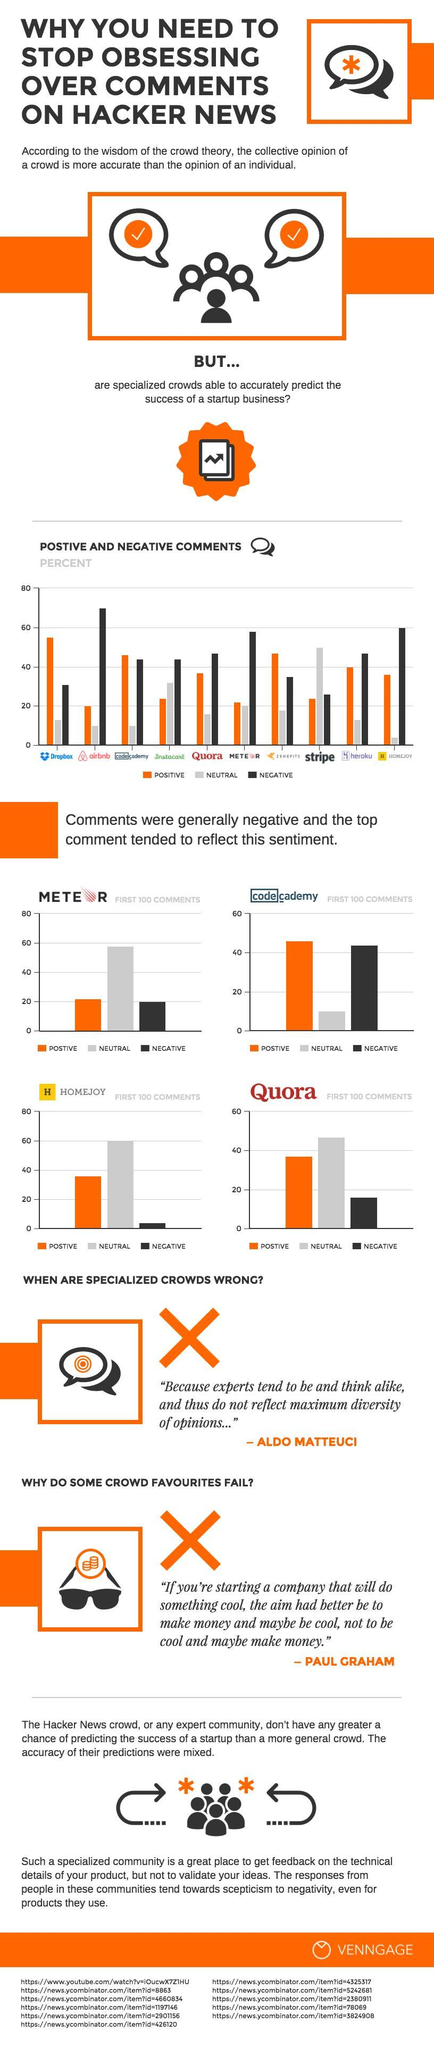In the first 100 comments for codecademy, which type was the most - positive, negative or neutral?
Answer the question with a short phrase. positive What was the percentage of negative comments for Airbnb? 70% Which website had the second highest percent of negative comments? HOMEJOY Which website had the least negative comments in the first 100 comments? HOMEJOY 